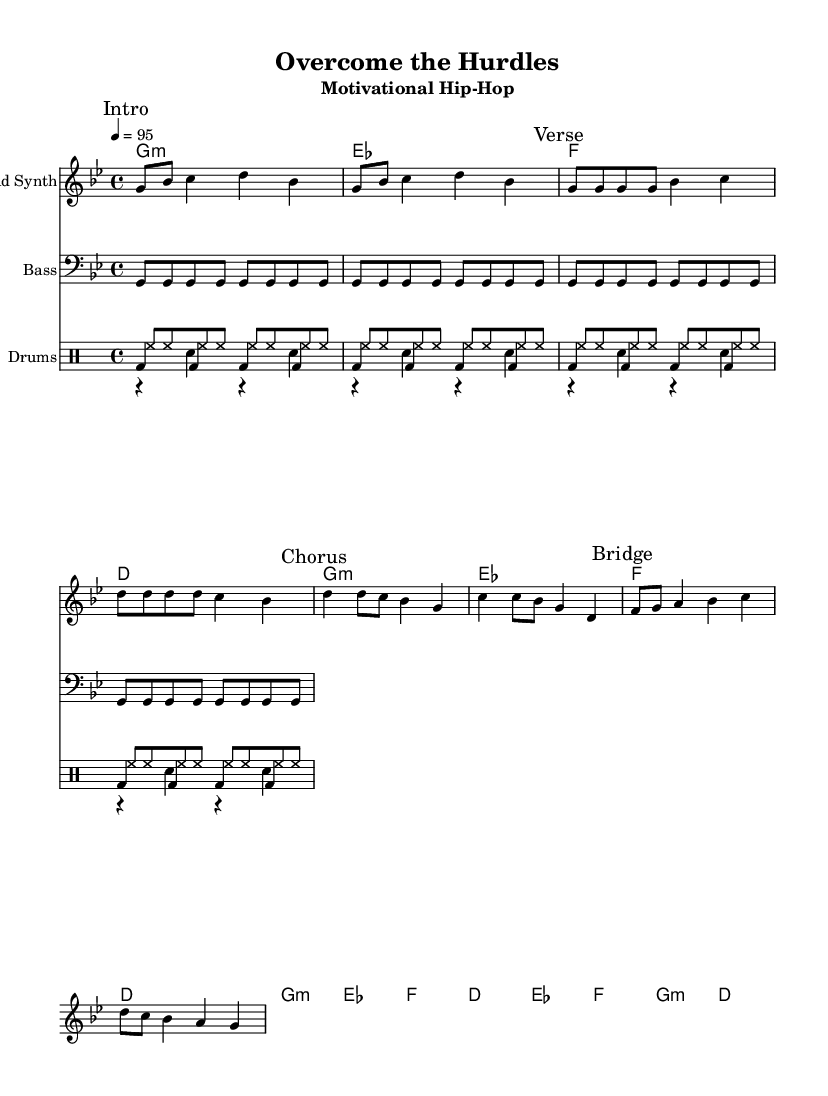What is the key signature of this music? The key signature is G minor, which contains two flats (B flat and E flat).
Answer: G minor What is the time signature of this piece? The time signature is 4/4, indicating four beats in each measure.
Answer: 4/4 What is the tempo marking for the piece? The tempo marking is 95 beats per minute, indicating a moderate speed.
Answer: 95 How many measures are in the "Chorus" section? The "Chorus" section contains two measures, indicated by the marked section and the corresponding notes.
Answer: 2 measures What type of synth is used as the lead instrument? The lead instrument is a Lead Synth, as indicated at the beginning of that staff.
Answer: Lead Synth What type of drums are included in the drum staff? The drum staff includes kick drum, snare drum, and hi-hat, as indicated by the labeled sections for each type.
Answer: Kick drum, snare drum, hi-hat Which section has the most notes played in a single measure? The "Bridge" section has the most notes played in a single measure, with a series of eighth notes and a quarter note.
Answer: Bridge 